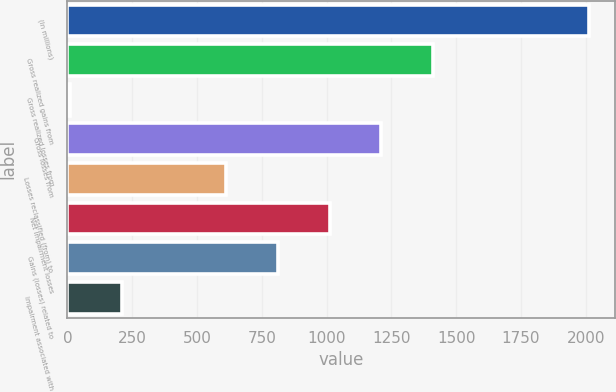Convert chart to OTSL. <chart><loc_0><loc_0><loc_500><loc_500><bar_chart><fcel>(In millions)<fcel>Gross realized gains from<fcel>Gross realized losses from<fcel>Gross losses from<fcel>Losses reclassified (from) to<fcel>Net impairment losses<fcel>Gains (losses) related to<fcel>Impairment associated with<nl><fcel>2011<fcel>1411.3<fcel>12<fcel>1211.4<fcel>611.7<fcel>1011.5<fcel>811.6<fcel>211.9<nl></chart> 